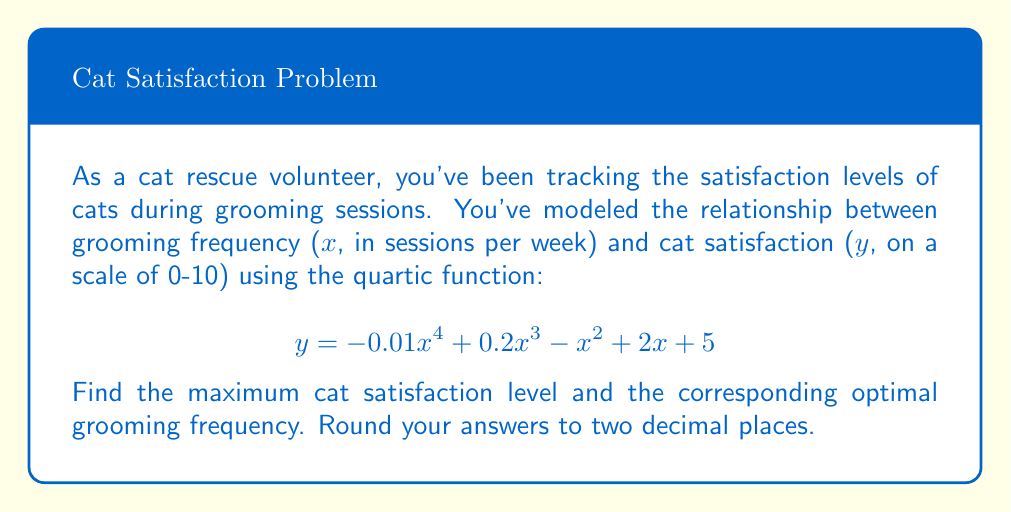Give your solution to this math problem. To find the maximum cat satisfaction level and the optimal grooming frequency, we need to follow these steps:

1) First, we need to find the derivative of the function:
   $$ \frac{dy}{dx} = -0.04x^3 + 0.6x^2 - 2x + 2 $$

2) Set the derivative equal to zero to find critical points:
   $$ -0.04x^3 + 0.6x^2 - 2x + 2 = 0 $$

3) This cubic equation is difficult to solve by hand, so we can use a graphing calculator or computer algebra system to find the roots. The roots are approximately:
   $x \approx -2.76, 1.95, 5.81$

4) Since we're dealing with grooming frequency, we can discard the negative root. We need to evaluate the original function at $x = 1.95$ and $x = 5.81$ to determine which gives the maximum satisfaction.

5) Evaluating the original function:
   For $x = 1.95$: $y \approx 7.96$
   For $x = 5.81$: $y \approx 6.76$

6) The maximum satisfaction occurs at $x \approx 1.95$ sessions per week, with a satisfaction level of $y \approx 7.96$.

7) Rounding to two decimal places:
   Optimal grooming frequency: 1.95 sessions/week
   Maximum cat satisfaction: 7.96
Answer: 1.95 sessions/week, 7.96 